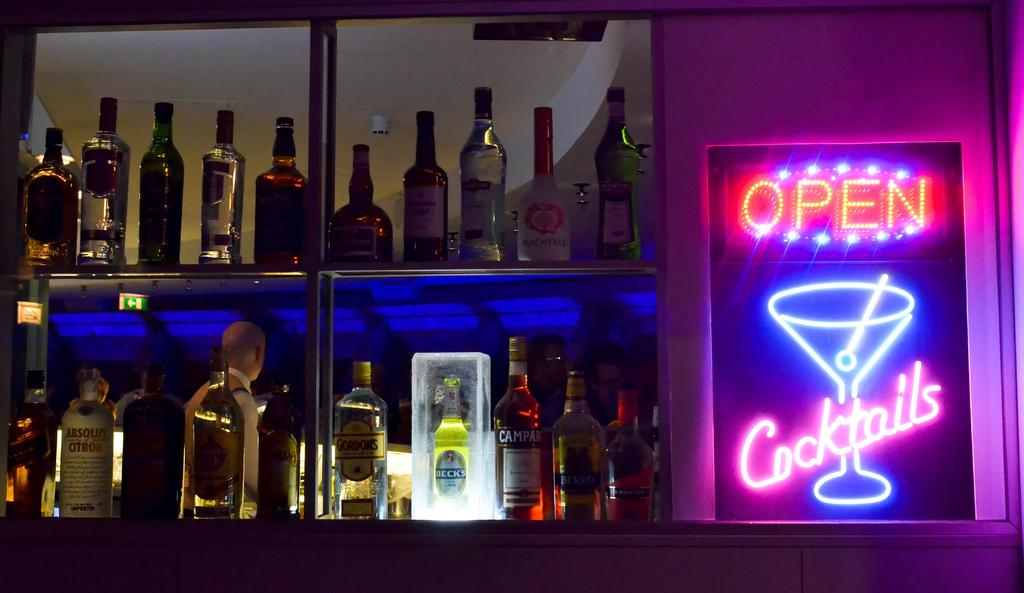<image>
Share a concise interpretation of the image provided. A lot of booze bottles on shelves next to an Open sign. 